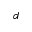Convert formula to latex. <formula><loc_0><loc_0><loc_500><loc_500>d</formula> 